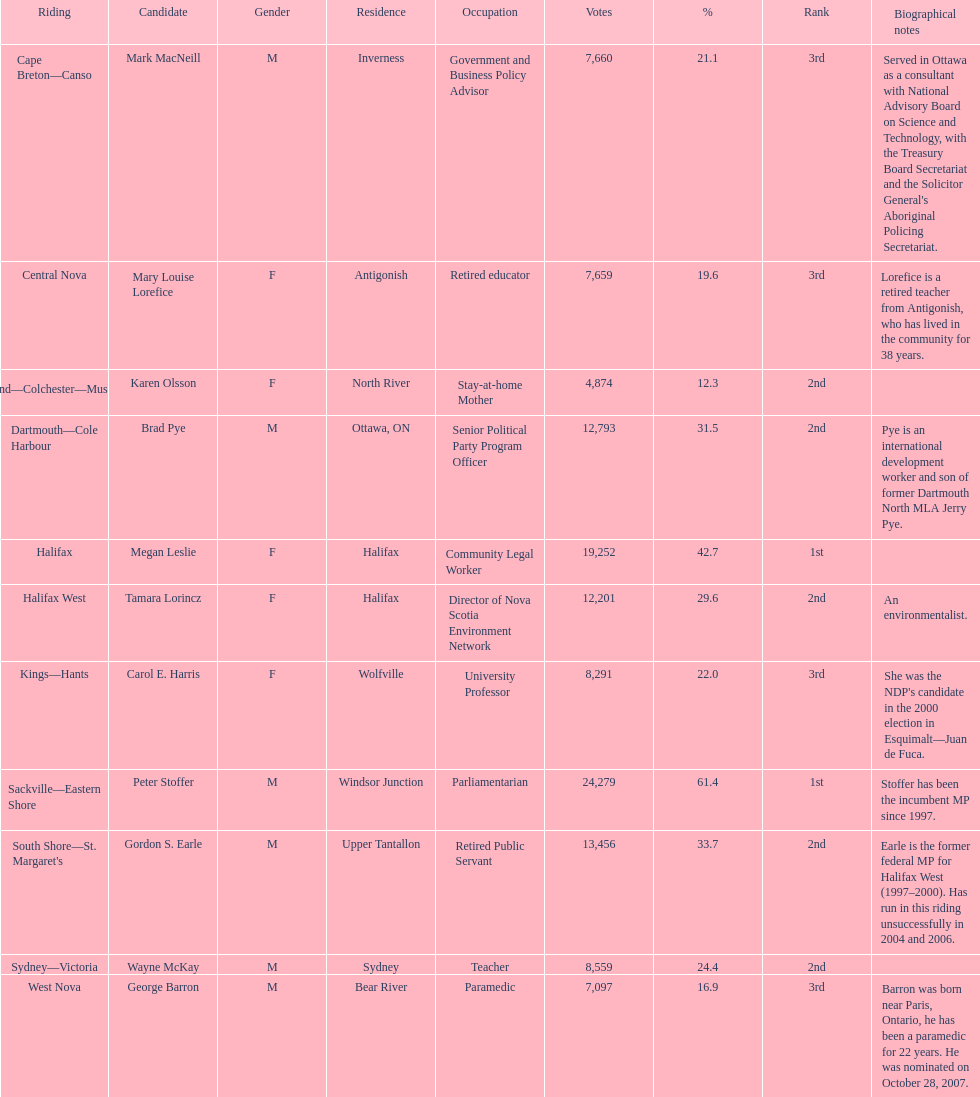What is the overall count of candidates? 11. 